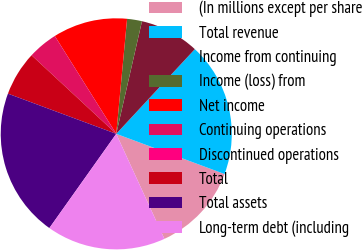<chart> <loc_0><loc_0><loc_500><loc_500><pie_chart><fcel>(In millions except per share<fcel>Total revenue<fcel>Income from continuing<fcel>Income (loss) from<fcel>Net income<fcel>Continuing operations<fcel>Discontinued operations<fcel>Total<fcel>Total assets<fcel>Long-term debt (including<nl><fcel>12.5%<fcel>18.75%<fcel>8.33%<fcel>2.08%<fcel>10.42%<fcel>4.17%<fcel>0.0%<fcel>6.25%<fcel>20.83%<fcel>16.67%<nl></chart> 